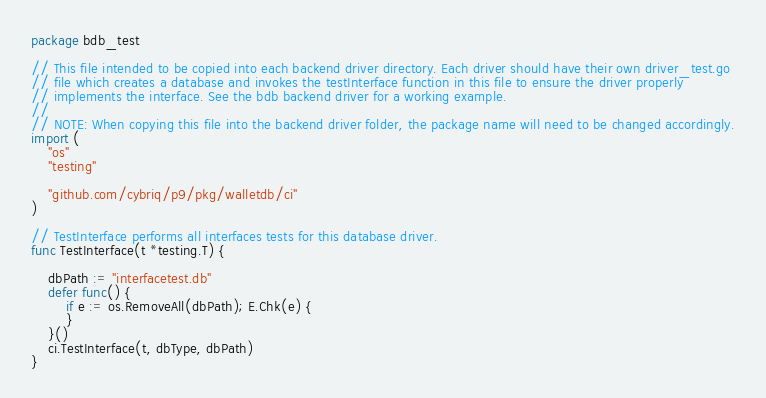<code> <loc_0><loc_0><loc_500><loc_500><_Go_>package bdb_test

// This file intended to be copied into each backend driver directory. Each driver should have their own driver_test.go
// file which creates a database and invokes the testInterface function in this file to ensure the driver properly
// implements the interface. See the bdb backend driver for a working example.
//
// NOTE: When copying this file into the backend driver folder, the package name will need to be changed accordingly.
import (
	"os"
	"testing"

	"github.com/cybriq/p9/pkg/walletdb/ci"
)

// TestInterface performs all interfaces tests for this database driver.
func TestInterface(t *testing.T) {

	dbPath := "interfacetest.db"
	defer func() {
		if e := os.RemoveAll(dbPath); E.Chk(e) {
		}
	}()
	ci.TestInterface(t, dbType, dbPath)
}
</code> 